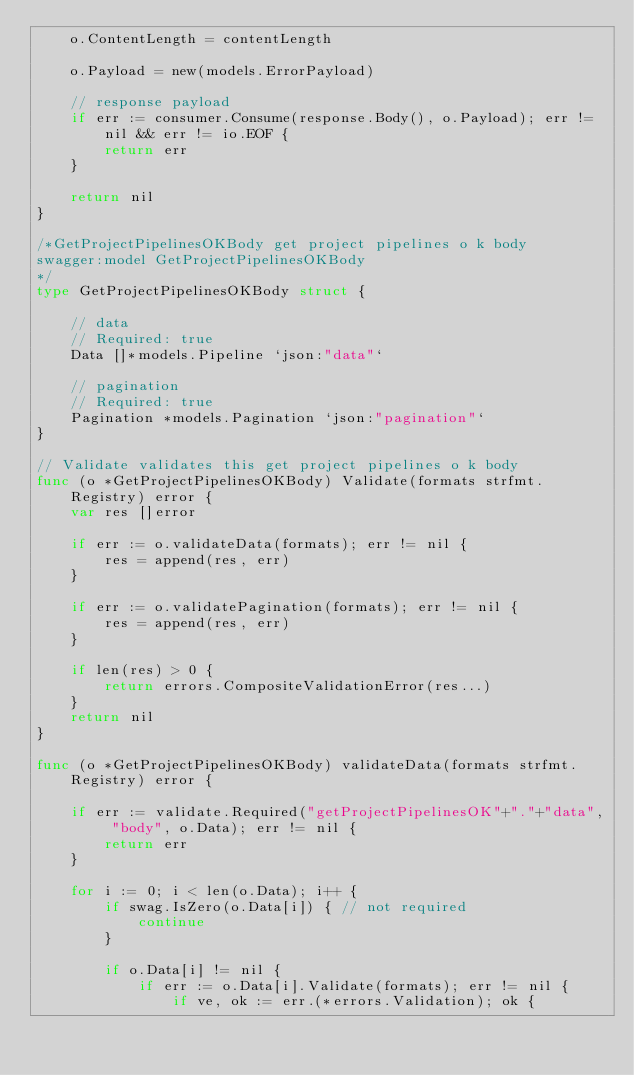<code> <loc_0><loc_0><loc_500><loc_500><_Go_>	o.ContentLength = contentLength

	o.Payload = new(models.ErrorPayload)

	// response payload
	if err := consumer.Consume(response.Body(), o.Payload); err != nil && err != io.EOF {
		return err
	}

	return nil
}

/*GetProjectPipelinesOKBody get project pipelines o k body
swagger:model GetProjectPipelinesOKBody
*/
type GetProjectPipelinesOKBody struct {

	// data
	// Required: true
	Data []*models.Pipeline `json:"data"`

	// pagination
	// Required: true
	Pagination *models.Pagination `json:"pagination"`
}

// Validate validates this get project pipelines o k body
func (o *GetProjectPipelinesOKBody) Validate(formats strfmt.Registry) error {
	var res []error

	if err := o.validateData(formats); err != nil {
		res = append(res, err)
	}

	if err := o.validatePagination(formats); err != nil {
		res = append(res, err)
	}

	if len(res) > 0 {
		return errors.CompositeValidationError(res...)
	}
	return nil
}

func (o *GetProjectPipelinesOKBody) validateData(formats strfmt.Registry) error {

	if err := validate.Required("getProjectPipelinesOK"+"."+"data", "body", o.Data); err != nil {
		return err
	}

	for i := 0; i < len(o.Data); i++ {
		if swag.IsZero(o.Data[i]) { // not required
			continue
		}

		if o.Data[i] != nil {
			if err := o.Data[i].Validate(formats); err != nil {
				if ve, ok := err.(*errors.Validation); ok {</code> 